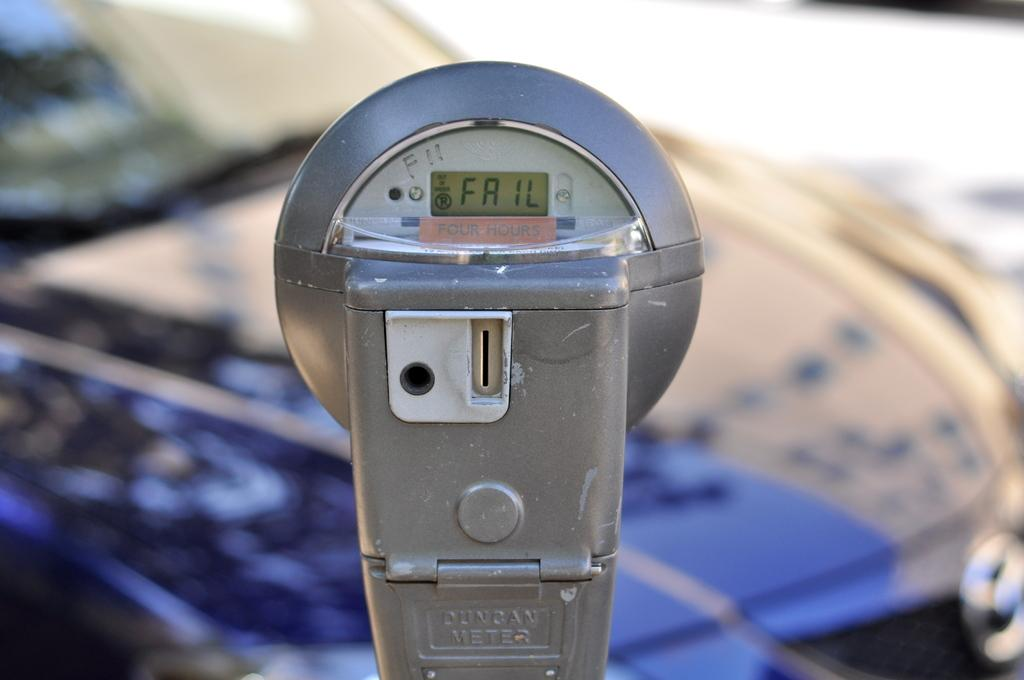<image>
Offer a succinct explanation of the picture presented. A parking meter is reading failed on the screen. 